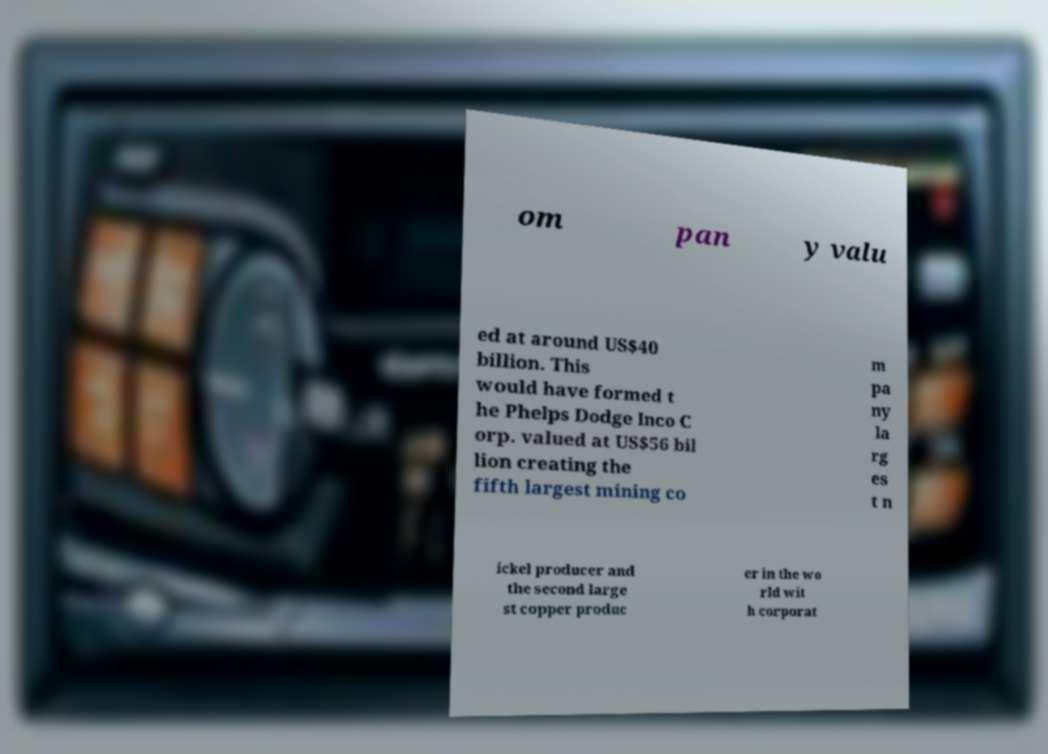What messages or text are displayed in this image? I need them in a readable, typed format. om pan y valu ed at around US$40 billion. This would have formed t he Phelps Dodge Inco C orp. valued at US$56 bil lion creating the fifth largest mining co m pa ny la rg es t n ickel producer and the second large st copper produc er in the wo rld wit h corporat 